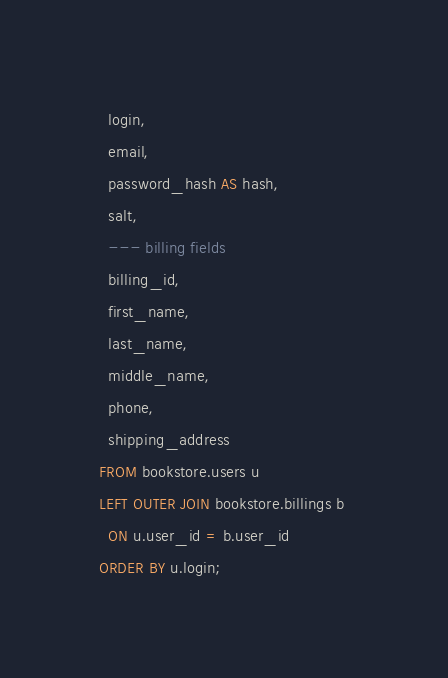<code> <loc_0><loc_0><loc_500><loc_500><_SQL_>  login,
  email,
  password_hash AS hash,
  salt,
  --- billing fields
  billing_id,
  first_name,
  last_name,
  middle_name,
  phone,
  shipping_address
FROM bookstore.users u
LEFT OUTER JOIN bookstore.billings b 
  ON u.user_id = b.user_id
ORDER BY u.login;
</code> 